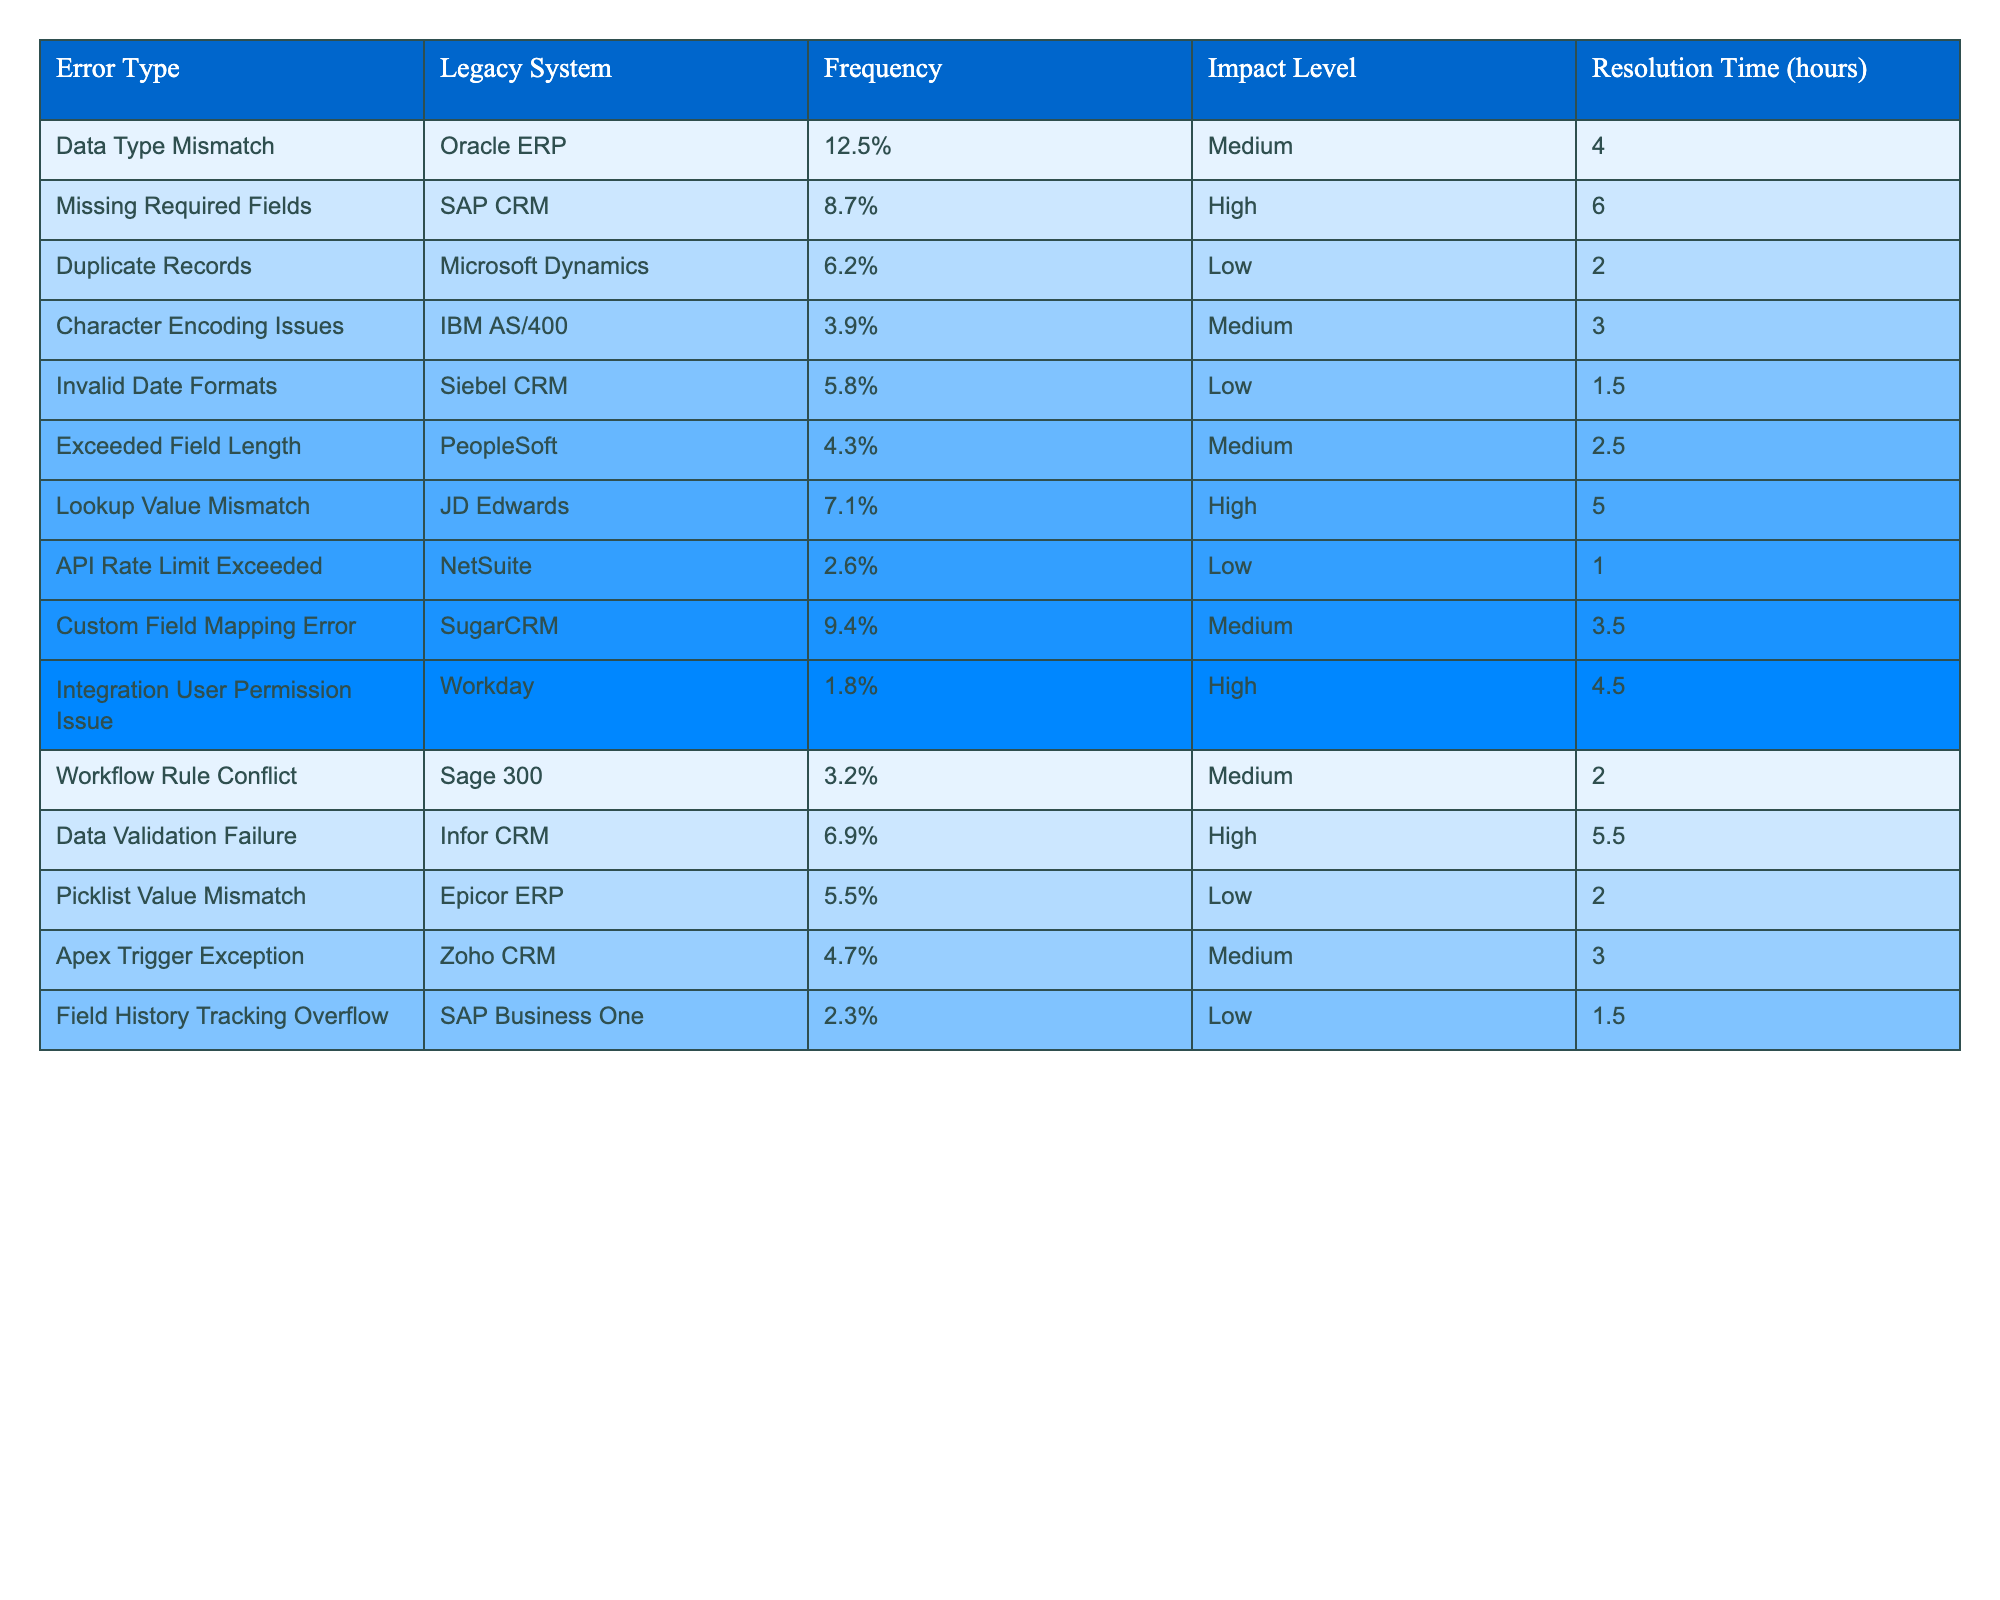What is the frequency of the Missing Required Fields error? The table indicates that the frequency of the Missing Required Fields error is listed as 8.7%.
Answer: 8.7% Which error type has the highest impact level? The Missing Required Fields, Lookup Value Mismatch, Integration User Permission Issue, and Data Validation Failure errors all have a high impact level. However, since Missing Required Fields has the highest frequency (8.7%), it can be considered the most significant in terms of impact level.
Answer: Missing Required Fields How many error types have a Medium resolution time of more than 3 hours? Looking at the resolution times in the table, the following errors have resolution times greater than 3 hours: Data Type Mismatch (4 hours), Custom Field Mapping Error (3.5 hours), and Data Validation Failure (5.5 hours). That accounts for a total of 3 errors.
Answer: 3 Which legacy system encountered the lowest frequency error? The error with the lowest frequency is the API Rate Limit Exceeded error at 2.6%, indicating that this error is less common among the legacy systems listed.
Answer: API Rate Limit Exceeded What is the average resolution time for all error types? Summing the resolution times: (4 + 6 + 2 + 3 + 1.5 + 2.5 + 5 + 1 + 3.5 + 4.5 + 2 + 5.5 + 2 + 3) results in a total of 39 hours across 14 error types. Dividing by 14 gives an average resolution time of approximately 2.79 hours.
Answer: Approximately 2.79 hours Is there at least one error type that has a low frequency and high impact? Analyzing the table, we find that Duplicate Records (6.2% frequency, low impact) and Picklist Value Mismatch (5.5% frequency, low impact) exist, indicating some errors are low in frequency but with a high impact rate tied to other errors.
Answer: Yes What is the total frequency of all Medium impact errors? To find the total frequency of Medium impact errors, add the percentages of the following errors: Data Type Mismatch (12.5%) + Character Encoding Issues (3.9%) + Exceeded Field Length (4.3%) + Custom Field Mapping Error (9.4%) + Apex Trigger Exception (4.7%) = 34.8%.
Answer: 34.8% Which legacy system has the highest frequency of errors, and what is that frequency? The Oracle ERP system has the highest frequency error type with 12.5% related to Data Type Mismatch.
Answer: Oracle ERP, 12.5% Are there more high impact errors or low impact errors in total? By counting, there are six high impact errors (Missing Required Fields, Lookup Value Mismatch, Integration User Permission Issue, Data Validation Failure) and eight low impact errors (Duplicate Records, Character Encoding Issues, Invalid Date Formats, Exceeded Field Length, API Rate Limit Exceeded, Picklist Value Mismatch, Field History Tracking Overflow). Therefore, there are more low impact errors.
Answer: More low impact errors What percentage of errors are due to the SAP CRM legacy system? The table indicates that the only error associated with the SAP CRM system (Missing Required Fields) has a frequency of 8.7%.
Answer: 8.7% 